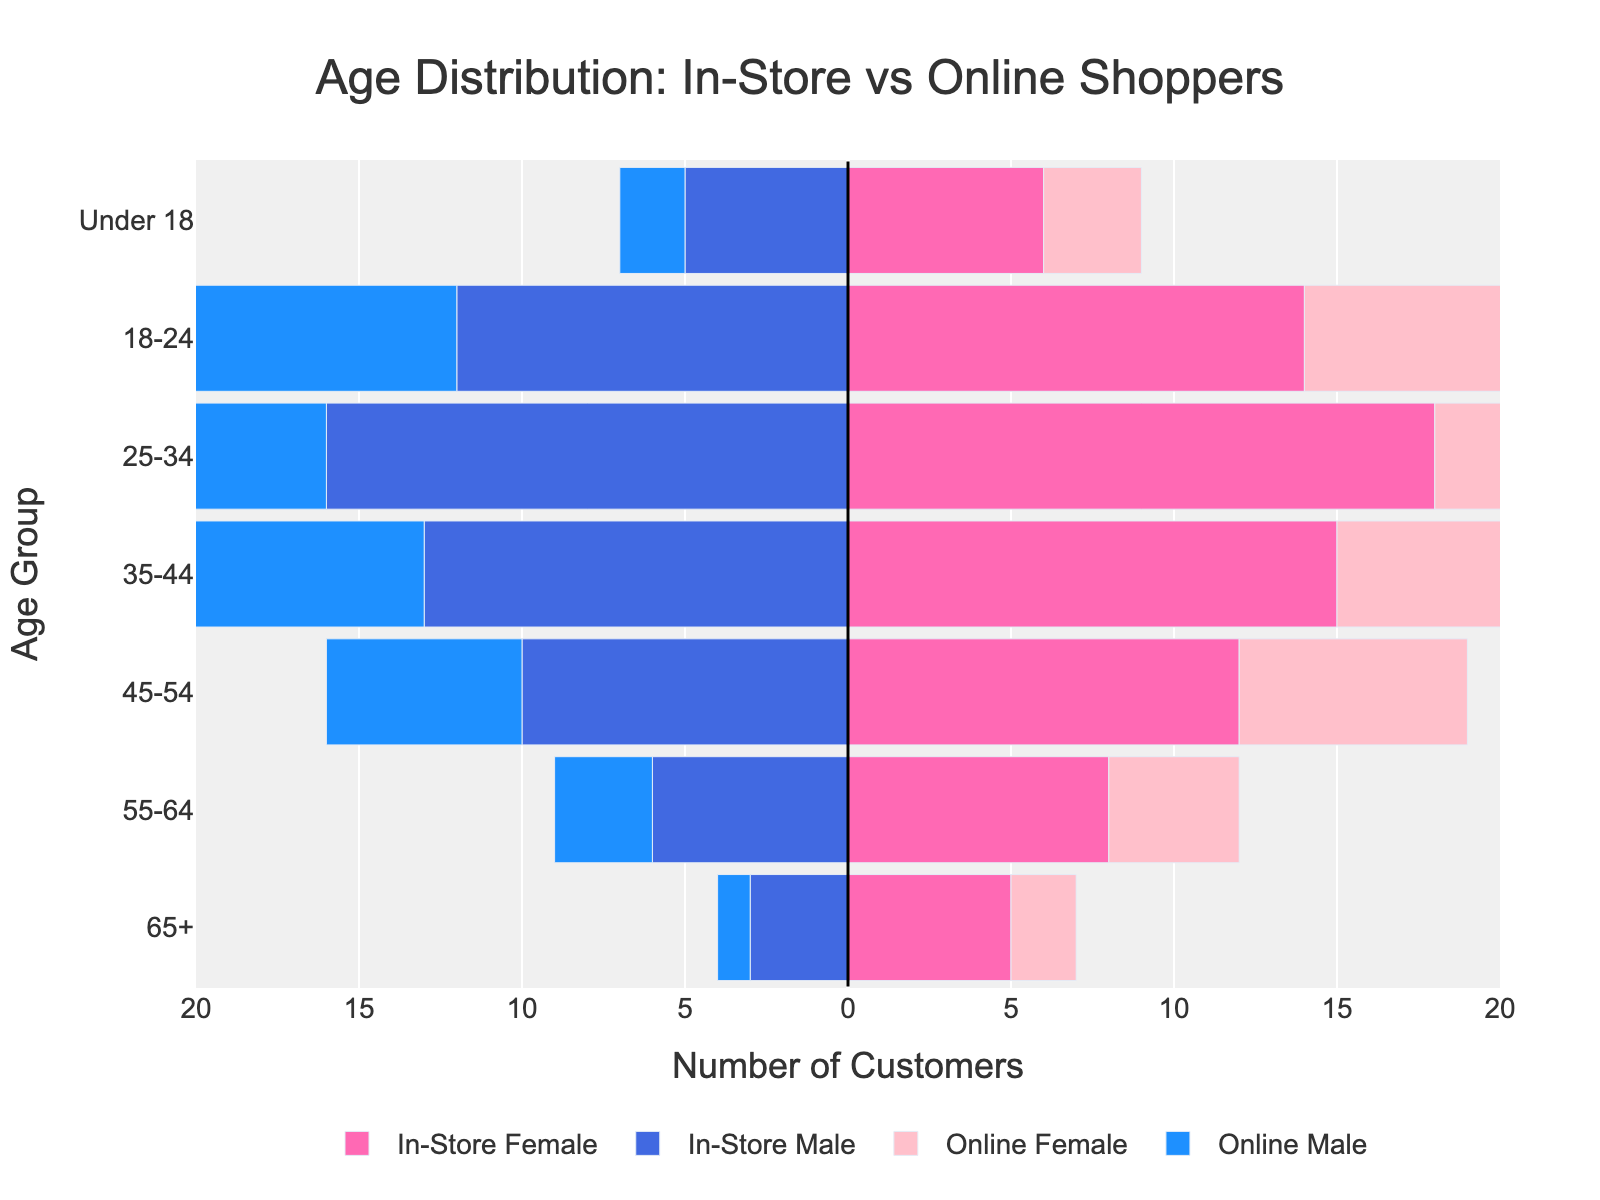What is the title of the plot? The title is located at the top of the figure and clearly displays the main topic of the plot.
Answer: Age Distribution: In-Store vs Online Shoppers Which age group has the highest number of in-store female customers? To determine the age group with the highest number, look at the visual length of the bars for in-store females.
Answer: 25-34 What colors represent online male and online female customers? Identify the colors used for the respective groups by looking at the legend.
Answer: Light blue for online males, light pink for online females How many in-store male customers are in the 18-24 age group? Find the bar for in-store males under the 18-24 age group and check its length/value, shown in negative since it is on the left.
Answer: 12 What is the total number of 45-54 in-store customers (both male and female)? Sum the number of in-store female and in-store male customers for the 45-54 age group. 12 (female) + 10 (male) = 22
Answer: 22 Which age group has more online female customers compared to in-store female customers? Compare the lengths of the bars for online females and in-store females for each age group.
Answer: 18-24 What is the difference between in-store and online male customers in the 25-34 age group? Subtract the number of online male customers from the number of in-store male customers in the 25-34 age group. 16 (in-store males) - 12 (online males) = 4
Answer: 4 Which age group has fewer male customers (both in-store and online) than the 18-24 age group? Compare the number of male customers (sum of in-store and online) in other age groups to the 18-24 male customers. Only the "Under 18" category has fewer.
Answer: Under 18 How many online customers are in the 65+ age group in total? Sum the number of online female and online male customers in the 65+ age group. 2 (female) + 1 (male) = 3
Answer: 3 Which group (in-store or online) has a higher number of customers in the 35-44 age group considering both genders? Sum the male and female customers for in-store and online groups separately, then compare the totals. In-store: 15 (female) + 13 (male) = 28; Online: 11 (female) + 9 (male) = 20
Answer: In-store 